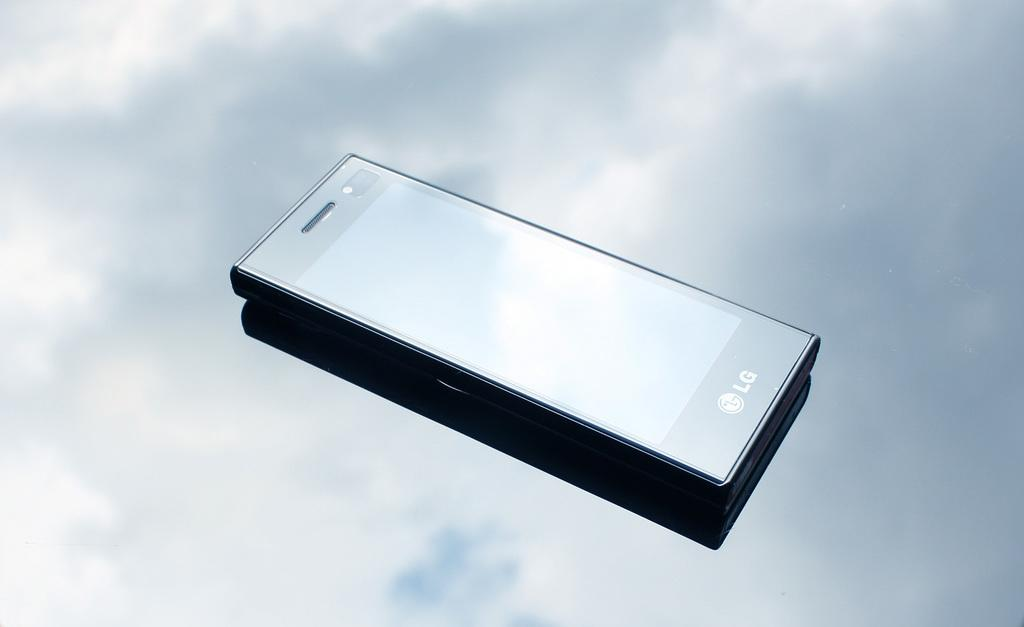Provide a one-sentence caption for the provided image. An LG phone is shown at an angle with clouds in the background. 